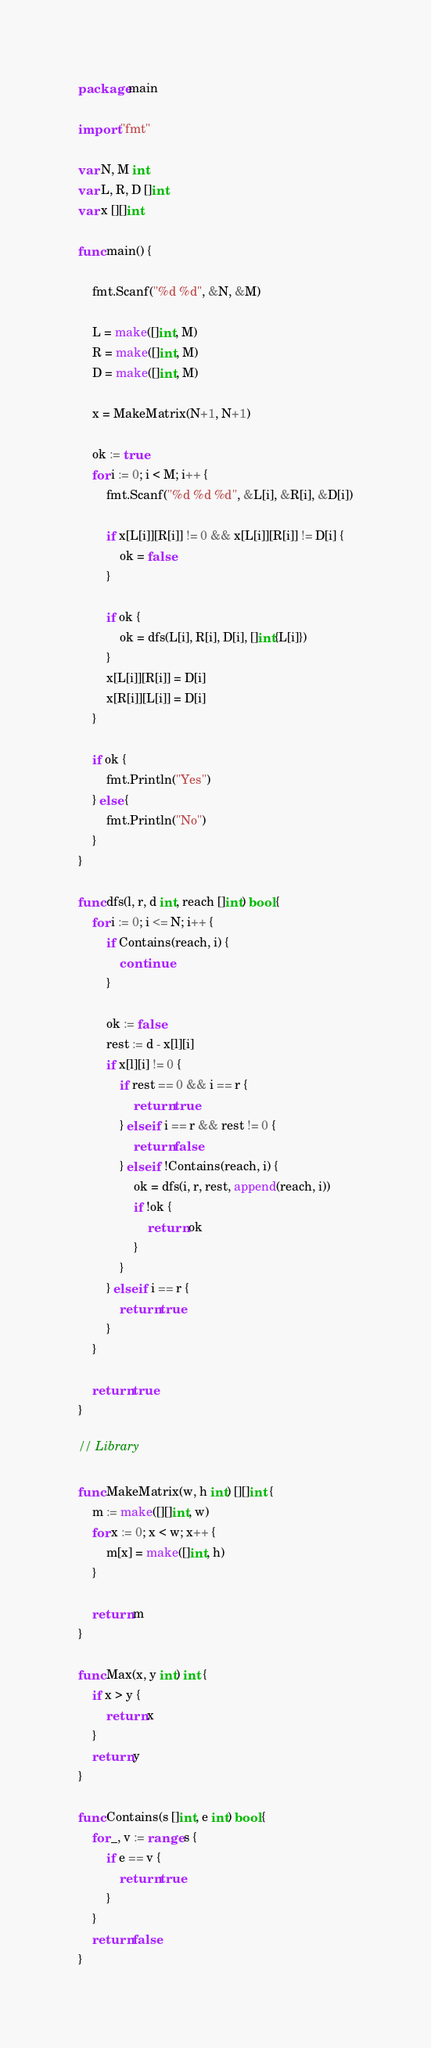<code> <loc_0><loc_0><loc_500><loc_500><_Go_>package main

import "fmt"

var N, M int
var L, R, D []int
var x [][]int

func main() {

	fmt.Scanf("%d %d", &N, &M)

	L = make([]int, M)
	R = make([]int, M)
	D = make([]int, M)

	x = MakeMatrix(N+1, N+1)

	ok := true
	for i := 0; i < M; i++ {
		fmt.Scanf("%d %d %d", &L[i], &R[i], &D[i])

		if x[L[i]][R[i]] != 0 && x[L[i]][R[i]] != D[i] {
			ok = false
		}

		if ok {
			ok = dfs(L[i], R[i], D[i], []int{L[i]})
		}
		x[L[i]][R[i]] = D[i]
		x[R[i]][L[i]] = D[i]
	}

	if ok {
		fmt.Println("Yes")
	} else {
		fmt.Println("No")
	}
}

func dfs(l, r, d int, reach []int) bool {
	for i := 0; i <= N; i++ {
		if Contains(reach, i) {
			continue
		}

		ok := false
		rest := d - x[l][i]
		if x[l][i] != 0 {
			if rest == 0 && i == r {
				return true
			} else if i == r && rest != 0 {
				return false
			} else if !Contains(reach, i) {
				ok = dfs(i, r, rest, append(reach, i))
				if !ok {
					return ok
				}
			}
		} else if i == r {
			return true
		}
	}

	return true
}

// Library

func MakeMatrix(w, h int) [][]int {
	m := make([][]int, w)
	for x := 0; x < w; x++ {
		m[x] = make([]int, h)
	}

	return m
}

func Max(x, y int) int {
	if x > y {
		return x
	}
	return y
}

func Contains(s []int, e int) bool {
	for _, v := range s {
		if e == v {
			return true
		}
	}
	return false
}
</code> 